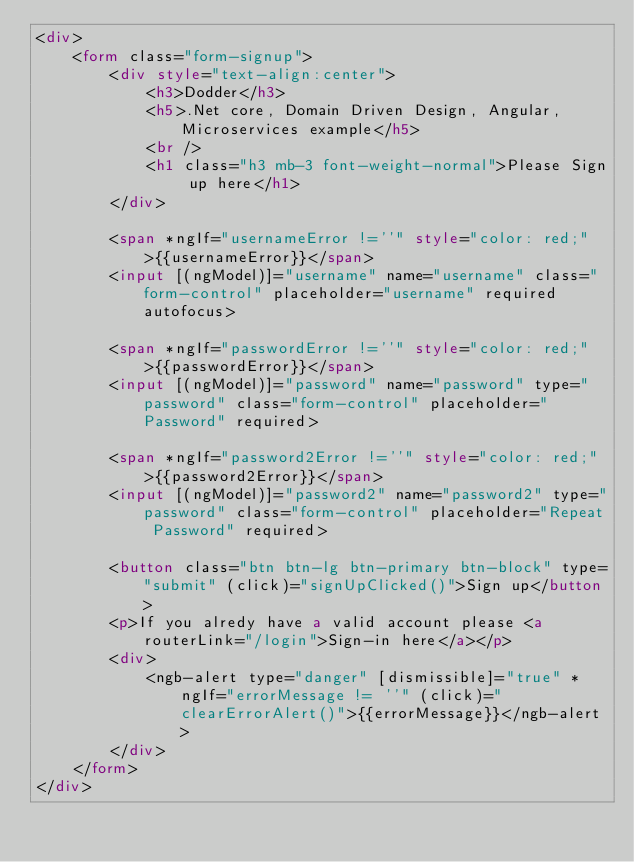<code> <loc_0><loc_0><loc_500><loc_500><_HTML_><div>
    <form class="form-signup">
        <div style="text-align:center">
            <h3>Dodder</h3>
            <h5>.Net core, Domain Driven Design, Angular, Microservices example</h5>
            <br />
            <h1 class="h3 mb-3 font-weight-normal">Please Sign up here</h1>
        </div>

        <span *ngIf="usernameError !=''" style="color: red;">{{usernameError}}</span>
        <input [(ngModel)]="username" name="username" class="form-control" placeholder="username" required autofocus>

        <span *ngIf="passwordError !=''" style="color: red;">{{passwordError}}</span>
        <input [(ngModel)]="password" name="password" type="password" class="form-control" placeholder="Password" required>

        <span *ngIf="password2Error !=''" style="color: red;">{{password2Error}}</span>
        <input [(ngModel)]="password2" name="password2" type="password" class="form-control" placeholder="Repeat Password" required>

        <button class="btn btn-lg btn-primary btn-block" type="submit" (click)="signUpClicked()">Sign up</button>
        <p>If you alredy have a valid account please <a routerLink="/login">Sign-in here</a></p>
        <div>
            <ngb-alert type="danger" [dismissible]="true" *ngIf="errorMessage != ''" (click)="clearErrorAlert()">{{errorMessage}}</ngb-alert>
        </div>
    </form>
</div>


</code> 